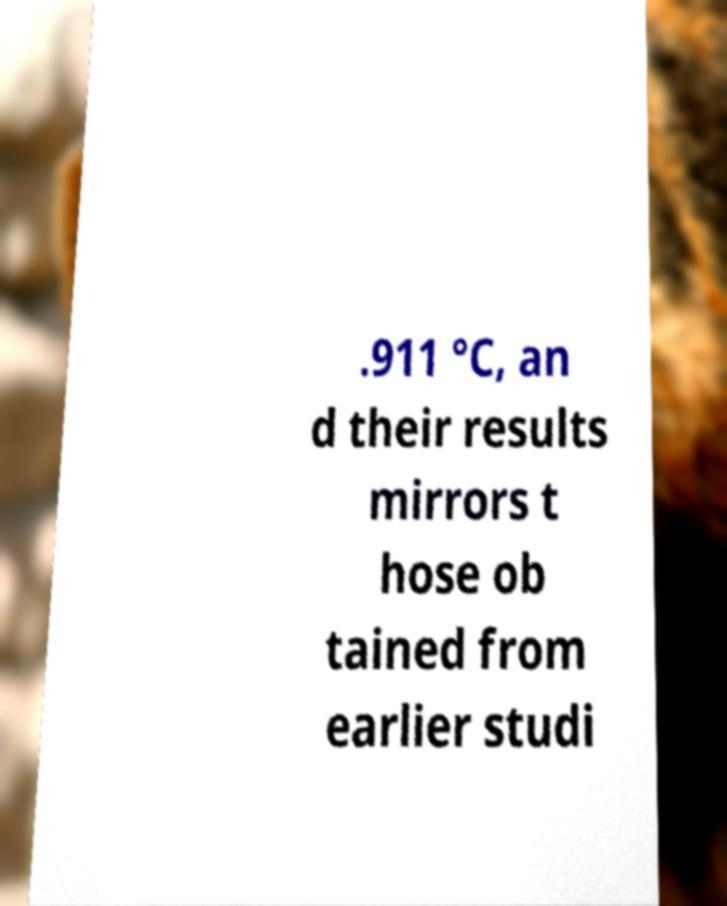There's text embedded in this image that I need extracted. Can you transcribe it verbatim? .911 °C, an d their results mirrors t hose ob tained from earlier studi 